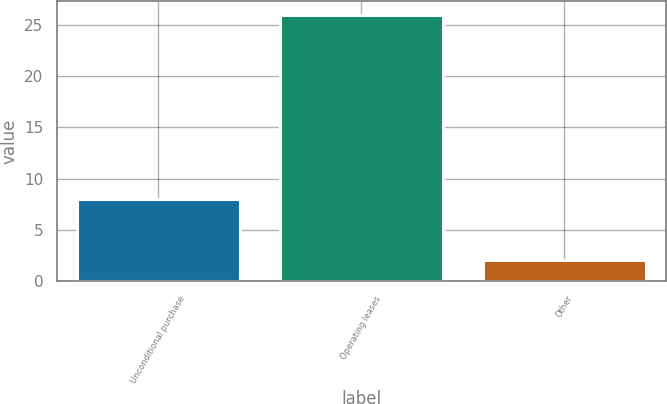Convert chart. <chart><loc_0><loc_0><loc_500><loc_500><bar_chart><fcel>Unconditional purchase<fcel>Operating leases<fcel>Other<nl><fcel>8<fcel>26<fcel>2<nl></chart> 